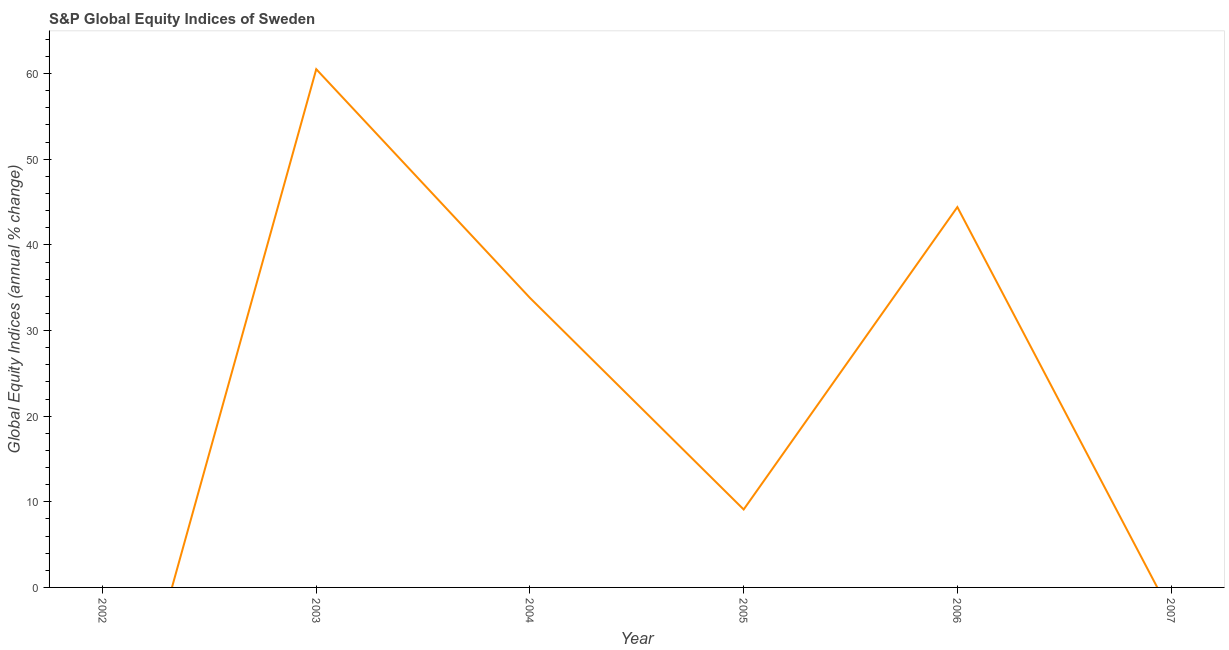What is the s&p global equity indices in 2002?
Provide a succinct answer. 0. Across all years, what is the maximum s&p global equity indices?
Ensure brevity in your answer.  60.51. Across all years, what is the minimum s&p global equity indices?
Make the answer very short. 0. In which year was the s&p global equity indices maximum?
Give a very brief answer. 2003. What is the sum of the s&p global equity indices?
Offer a very short reply. 147.84. What is the difference between the s&p global equity indices in 2003 and 2004?
Your answer should be very brief. 26.71. What is the average s&p global equity indices per year?
Provide a succinct answer. 24.64. What is the median s&p global equity indices?
Provide a succinct answer. 21.45. In how many years, is the s&p global equity indices greater than 4 %?
Offer a very short reply. 4. What is the ratio of the s&p global equity indices in 2005 to that in 2006?
Provide a succinct answer. 0.2. Is the s&p global equity indices in 2005 less than that in 2006?
Your response must be concise. Yes. Is the difference between the s&p global equity indices in 2003 and 2004 greater than the difference between any two years?
Make the answer very short. No. What is the difference between the highest and the second highest s&p global equity indices?
Offer a terse response. 16.1. What is the difference between the highest and the lowest s&p global equity indices?
Provide a short and direct response. 60.51. In how many years, is the s&p global equity indices greater than the average s&p global equity indices taken over all years?
Offer a terse response. 3. How many lines are there?
Your response must be concise. 1. How many years are there in the graph?
Provide a short and direct response. 6. Does the graph contain any zero values?
Ensure brevity in your answer.  Yes. What is the title of the graph?
Offer a terse response. S&P Global Equity Indices of Sweden. What is the label or title of the Y-axis?
Ensure brevity in your answer.  Global Equity Indices (annual % change). What is the Global Equity Indices (annual % change) of 2002?
Make the answer very short. 0. What is the Global Equity Indices (annual % change) of 2003?
Your response must be concise. 60.51. What is the Global Equity Indices (annual % change) of 2004?
Offer a very short reply. 33.81. What is the Global Equity Indices (annual % change) in 2005?
Give a very brief answer. 9.1. What is the Global Equity Indices (annual % change) in 2006?
Keep it short and to the point. 44.41. What is the Global Equity Indices (annual % change) of 2007?
Offer a very short reply. 0. What is the difference between the Global Equity Indices (annual % change) in 2003 and 2004?
Your answer should be compact. 26.71. What is the difference between the Global Equity Indices (annual % change) in 2003 and 2005?
Your answer should be very brief. 51.41. What is the difference between the Global Equity Indices (annual % change) in 2003 and 2006?
Your response must be concise. 16.1. What is the difference between the Global Equity Indices (annual % change) in 2004 and 2005?
Your answer should be compact. 24.71. What is the difference between the Global Equity Indices (annual % change) in 2004 and 2006?
Provide a short and direct response. -10.61. What is the difference between the Global Equity Indices (annual % change) in 2005 and 2006?
Make the answer very short. -35.31. What is the ratio of the Global Equity Indices (annual % change) in 2003 to that in 2004?
Your response must be concise. 1.79. What is the ratio of the Global Equity Indices (annual % change) in 2003 to that in 2005?
Make the answer very short. 6.65. What is the ratio of the Global Equity Indices (annual % change) in 2003 to that in 2006?
Your response must be concise. 1.36. What is the ratio of the Global Equity Indices (annual % change) in 2004 to that in 2005?
Ensure brevity in your answer.  3.71. What is the ratio of the Global Equity Indices (annual % change) in 2004 to that in 2006?
Offer a very short reply. 0.76. What is the ratio of the Global Equity Indices (annual % change) in 2005 to that in 2006?
Your response must be concise. 0.2. 